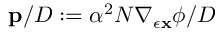<formula> <loc_0><loc_0><loc_500><loc_500>p / { D } \colon = \alpha ^ { 2 } N \nabla _ { \epsilon { x } } \phi / { D }</formula> 